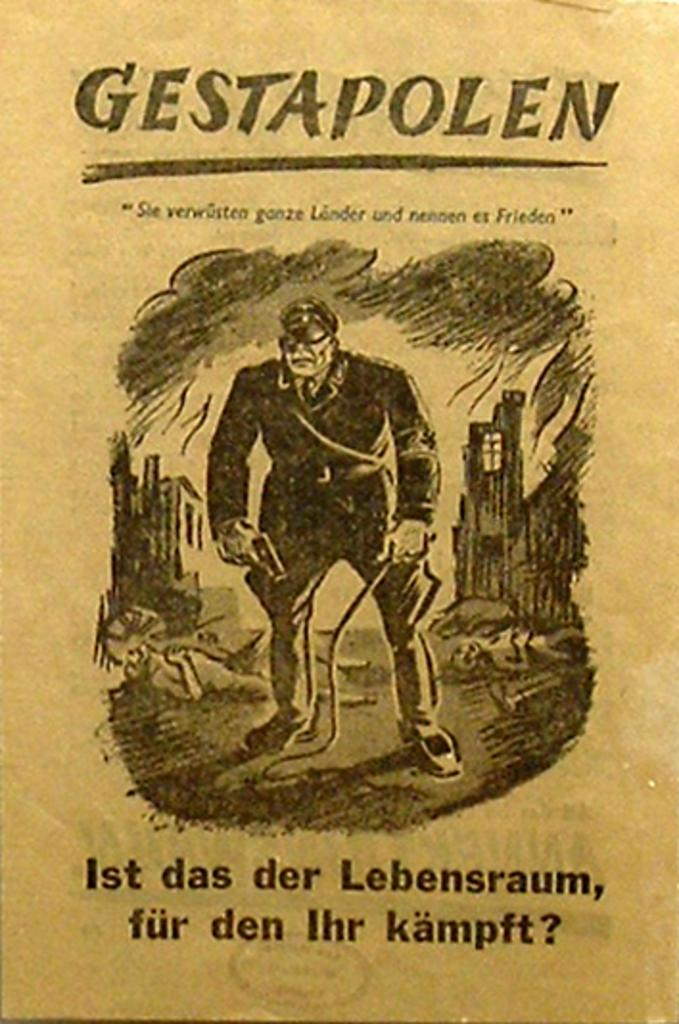What is the main subject of the image? There is a poster in the image. What can be seen on the poster? There are people depicted on the poster, along with objects and text. Can you tell me how many snails are depicted on the poster? There are no snails depicted on the poster; it features people, objects, and text. What type of expert is shown on the poster? There is no expert depicted on the poster; it features people, objects, and text. 